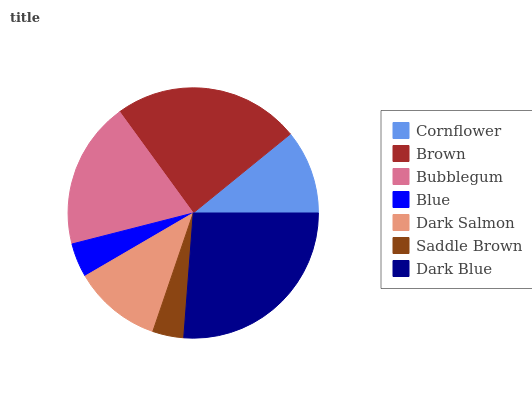Is Saddle Brown the minimum?
Answer yes or no. Yes. Is Dark Blue the maximum?
Answer yes or no. Yes. Is Brown the minimum?
Answer yes or no. No. Is Brown the maximum?
Answer yes or no. No. Is Brown greater than Cornflower?
Answer yes or no. Yes. Is Cornflower less than Brown?
Answer yes or no. Yes. Is Cornflower greater than Brown?
Answer yes or no. No. Is Brown less than Cornflower?
Answer yes or no. No. Is Dark Salmon the high median?
Answer yes or no. Yes. Is Dark Salmon the low median?
Answer yes or no. Yes. Is Brown the high median?
Answer yes or no. No. Is Brown the low median?
Answer yes or no. No. 